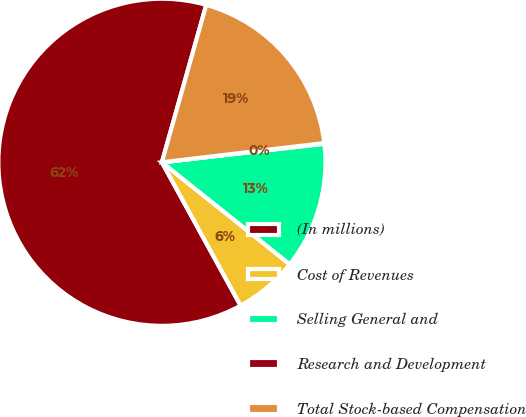Convert chart to OTSL. <chart><loc_0><loc_0><loc_500><loc_500><pie_chart><fcel>(In millions)<fcel>Cost of Revenues<fcel>Selling General and<fcel>Research and Development<fcel>Total Stock-based Compensation<nl><fcel>62.36%<fcel>6.29%<fcel>12.52%<fcel>0.07%<fcel>18.75%<nl></chart> 